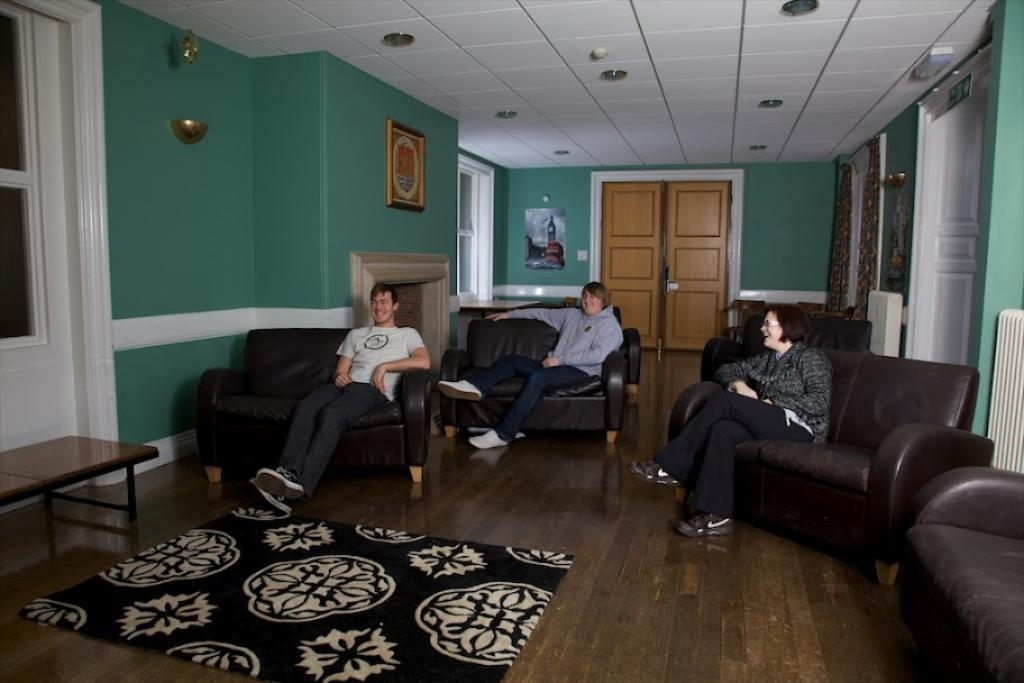What is present in the image? There are people in the image. What are the people doing in the image? The people are sitting on chairs. What type of behavior can be observed in the robin in the image? There is no robin present in the image, so it is not possible to observe any behavior. 